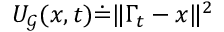<formula> <loc_0><loc_0><loc_500><loc_500>{ U _ { \mathcal { G } } ( x , t ) \dot { = } \| \Gamma _ { t } - x \| ^ { 2 } }</formula> 